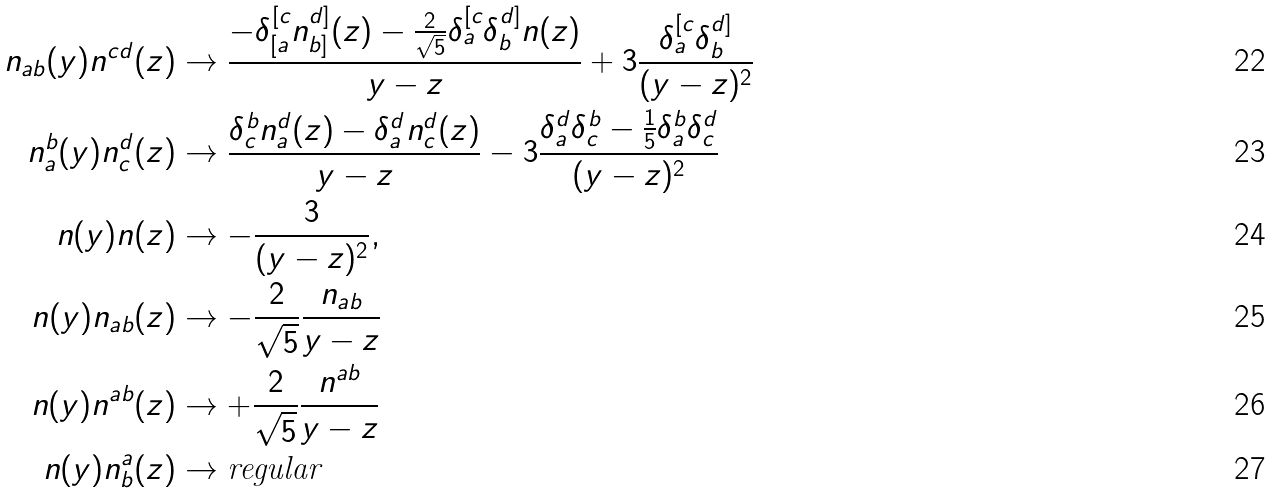<formula> <loc_0><loc_0><loc_500><loc_500>n _ { a b } ( y ) n ^ { c d } ( z ) & \rightarrow \frac { - \delta ^ { [ c } _ { [ a } n ^ { d ] } _ { b ] } ( z ) - \frac { 2 } { \sqrt { 5 } } \delta ^ { [ c } _ { a } \delta ^ { d ] } _ { b } n ( z ) } { y - z } + 3 \frac { \delta ^ { [ c } _ { a } \delta ^ { d ] } _ { b } } { ( y - z ) ^ { 2 } } \\ n _ { a } ^ { b } ( y ) n _ { c } ^ { d } ( z ) & \rightarrow \frac { \delta ^ { b } _ { c } n _ { a } ^ { d } ( z ) - \delta _ { a } ^ { d } n _ { c } ^ { d } ( z ) } { y - z } - 3 \frac { \delta _ { a } ^ { d } \delta _ { c } ^ { b } - \frac { 1 } { 5 } \delta ^ { b } _ { a } \delta _ { c } ^ { d } } { ( y - z ) ^ { 2 } } \\ n ( y ) n ( z ) & \rightarrow - \frac { 3 } { ( y - z ) ^ { 2 } } , \\ n ( y ) n _ { a b } ( z ) & \rightarrow - \frac { 2 } { \sqrt { 5 } } \frac { n _ { a b } } { y - z } \\ n ( y ) n ^ { a b } ( z ) & \rightarrow + \frac { 2 } { \sqrt { 5 } } \frac { n ^ { a b } } { y - z } \\ n ( y ) n ^ { a } _ { b } ( z ) & \rightarrow \text {regular}</formula> 